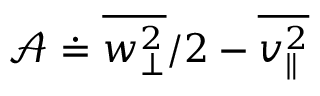Convert formula to latex. <formula><loc_0><loc_0><loc_500><loc_500>\mathcal { A } \doteq \overline { { w _ { \perp } ^ { 2 } } } / 2 - \overline { { v _ { \| } ^ { 2 } } }</formula> 